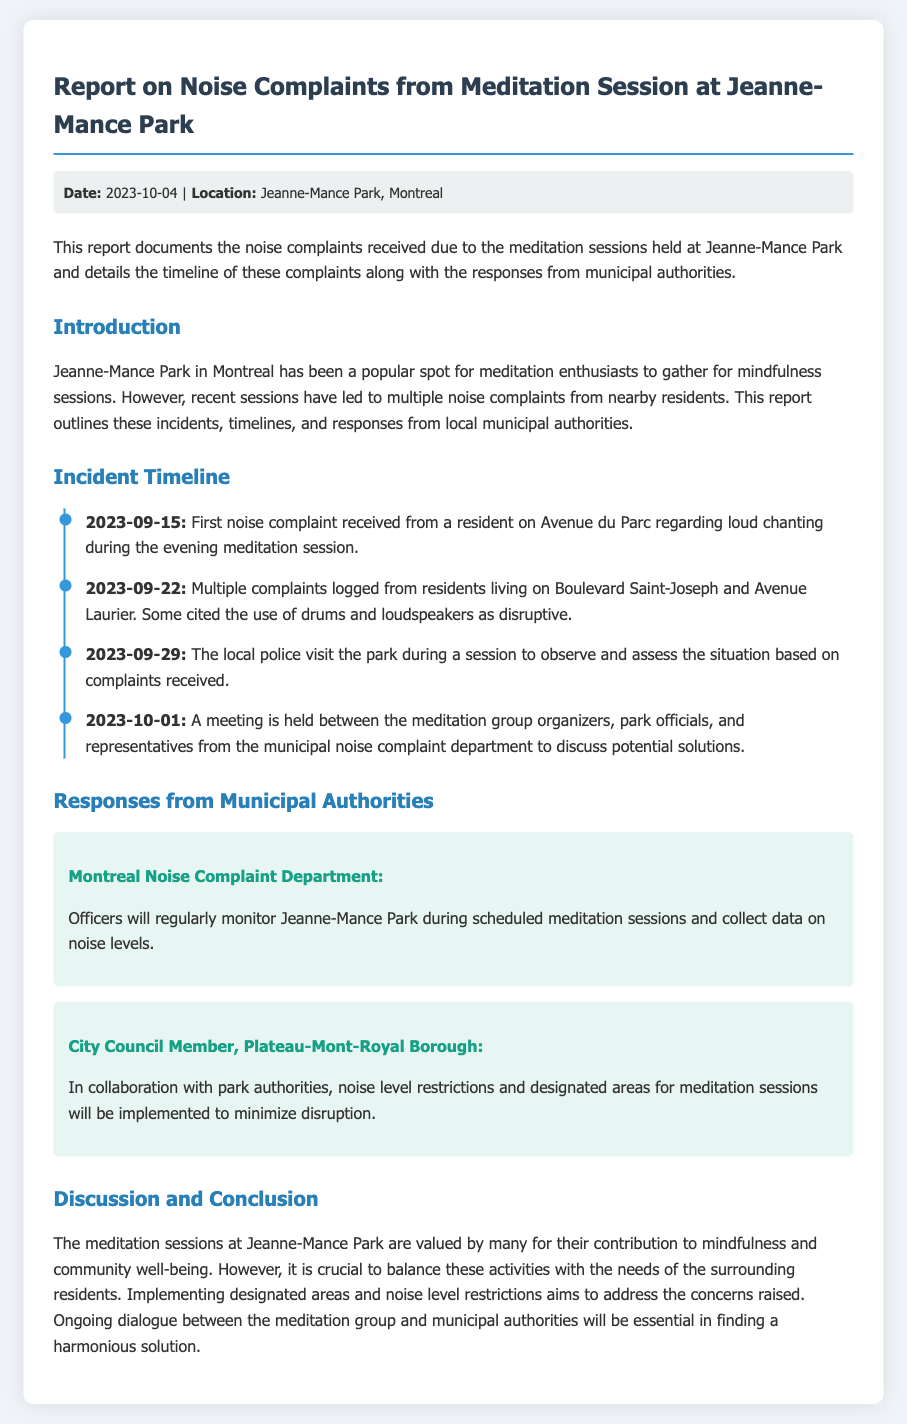what is the date of the report? The report explicitly states the date as 2023-10-04.
Answer: 2023-10-04 where did the meditation sessions take place? The location for the meditation sessions is mentioned as Jeanne-Mance Park in Montreal.
Answer: Jeanne-Mance Park what was the first complaint about? The first complaint was regarding loud chanting during the evening meditation session.
Answer: loud chanting who visited the park on 2023-09-29? The local police visited the park to observe and assess the situation based on complaints received.
Answer: local police what will the Noise Complaint Department do? The Montreal Noise Complaint Department will regularly monitor Jeanne-Mance Park during scheduled meditation sessions and collect data on noise levels.
Answer: regularly monitor what was discussed in the meeting on 2023-10-01? The meeting involved discussions between the meditation group organizers, park officials, and representatives from the municipal noise complaint department about potential solutions.
Answer: potential solutions what restriction is mentioned in the responses from municipal authorities? The responses mention that noise level restrictions and designated areas for meditation sessions will be implemented to minimize disruption.
Answer: noise level restrictions why are the meditation sessions valued? The meditation sessions are valued for their contribution to mindfulness and community well-being.
Answer: mindfulness and community well-being 